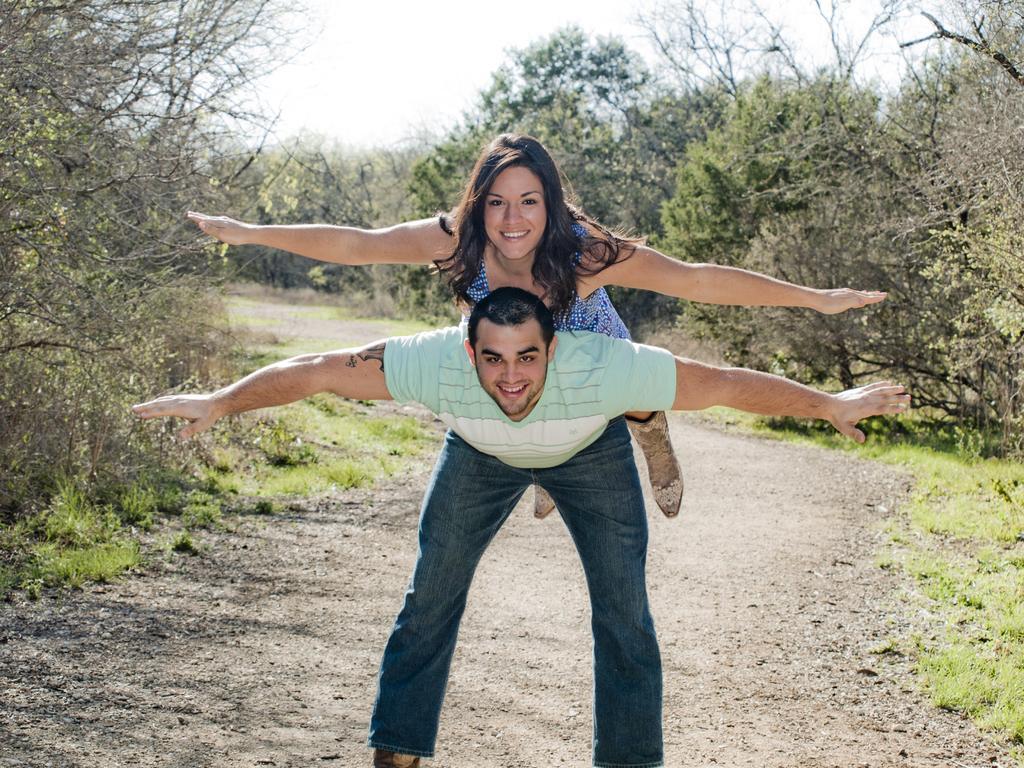Describe this image in one or two sentences. In this image we can see a woman on a man. Behind the persons we can see the grass and the trees. At the top we can see the sky. 